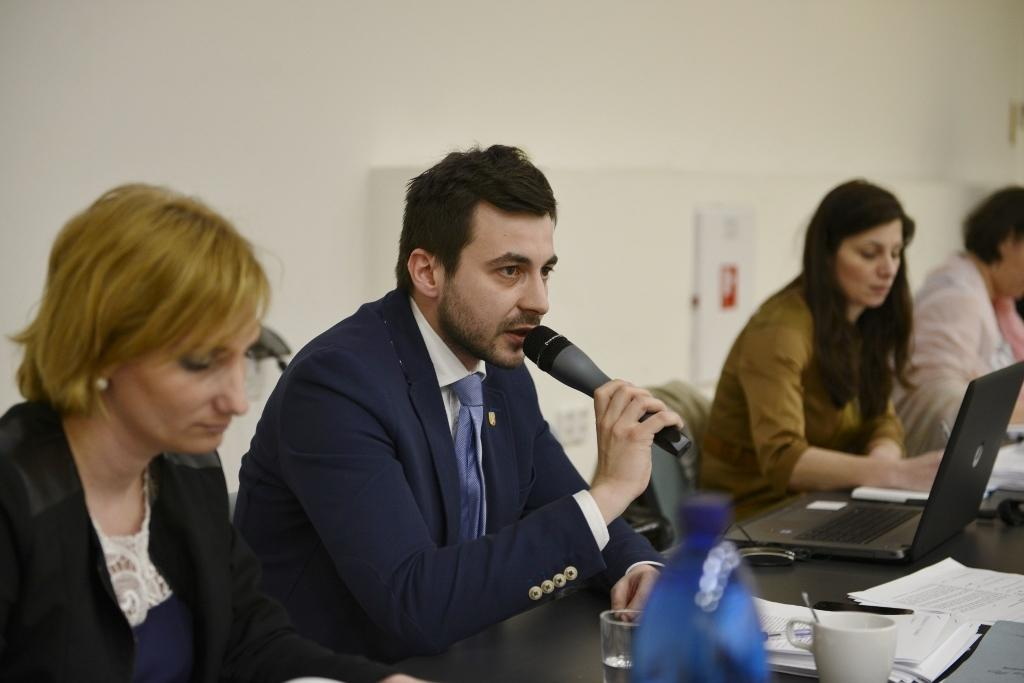What are the people in the image doing? The people in the image are sitting on chairs. Where are the chairs located in relation to the table? The chairs are in front of the table. What items can be seen on the table? There are papers, a laptop, and a cup on the table. What type of gun is the scarecrow holding in the image? There is no scarecrow or gun present in the image. What act are the people performing in the image? The image does not depict any specific act or performance; it simply shows people sitting on chairs in front of a table. 